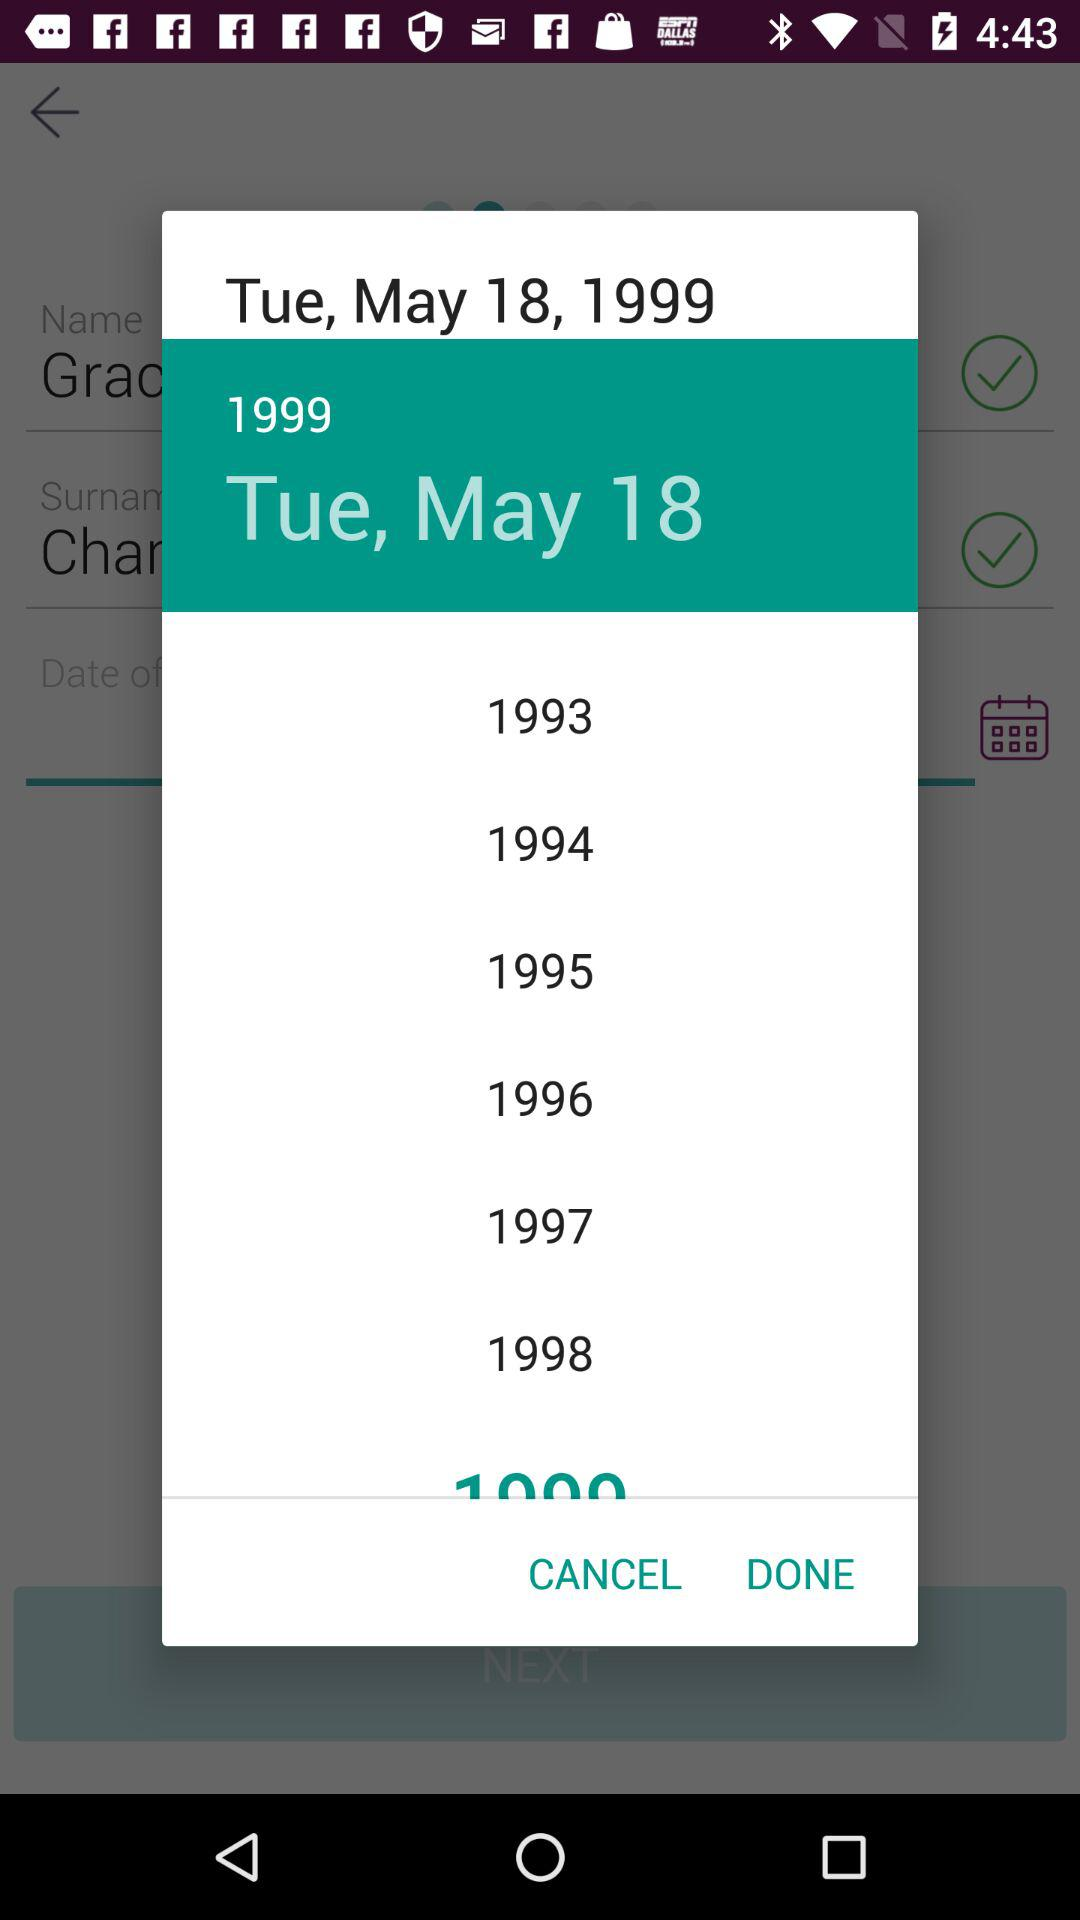How many years are between 1993 and 1999?
Answer the question using a single word or phrase. 6 